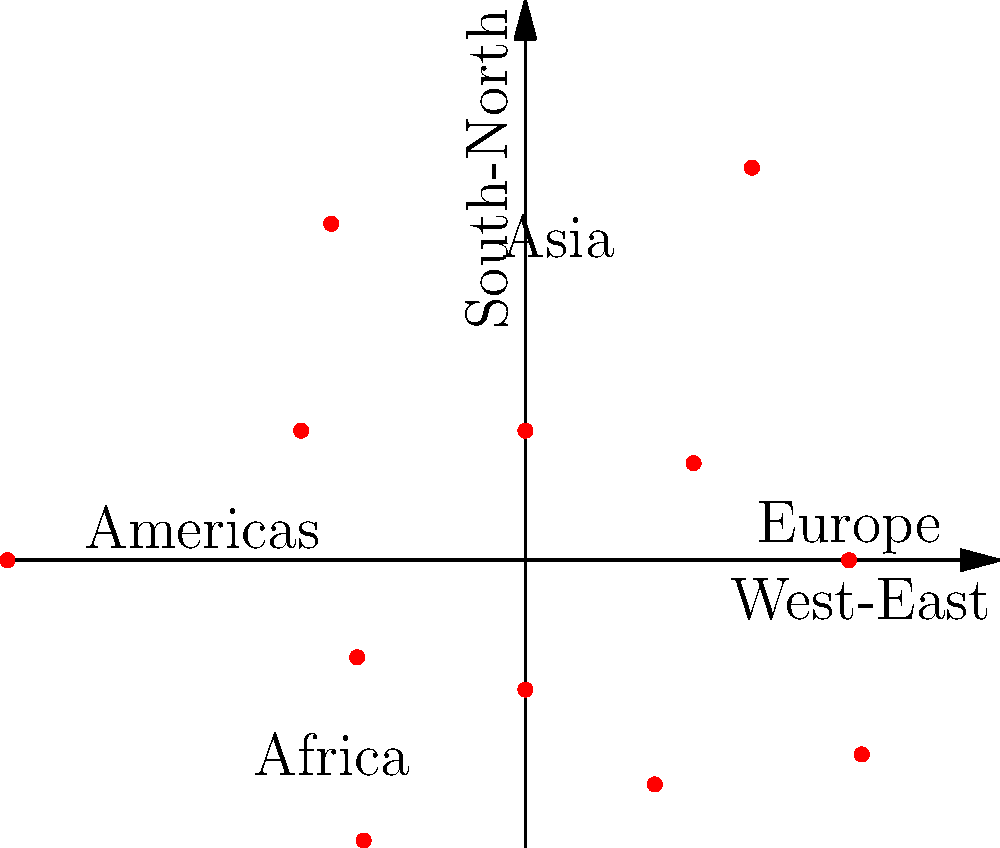As a Slovenian diplomat, you're analyzing the distribution of your country's embassies worldwide. The polar scatter plot above represents the locations of Slovenian embassies, where the angle corresponds to the geographic direction and the distance from the center indicates the number of embassies in that region. Based on this visualization, in which continental region does Slovenia appear to have the highest concentration of embassies? To determine the region with the highest concentration of Slovenian embassies, we need to analyze the polar scatter plot:

1. The plot is divided into four main regions, labeled Europe, Asia, Africa, and Americas.
2. Each point represents a group of embassies, with its distance from the center indicating the number of embassies.
3. We need to identify the region with the most points and/or points farthest from the center.

Analyzing each region:
- Europe (right side): Has several points, including the farthest point from the center.
- Asia (top): Has a few points, but they are relatively close to the center.
- Africa (bottom-left): Has fewer points, and they are closer to the center.
- Americas (left): Has a moderate number of points, but they are not as far from the center as those in Europe.

The European region clearly has the highest concentration of points, including the point farthest from the center, indicating the largest number of embassies in a single direction.

This aligns with Slovenia's geopolitical situation, as it is a European country and likely to have more diplomatic relations within Europe.
Answer: Europe 